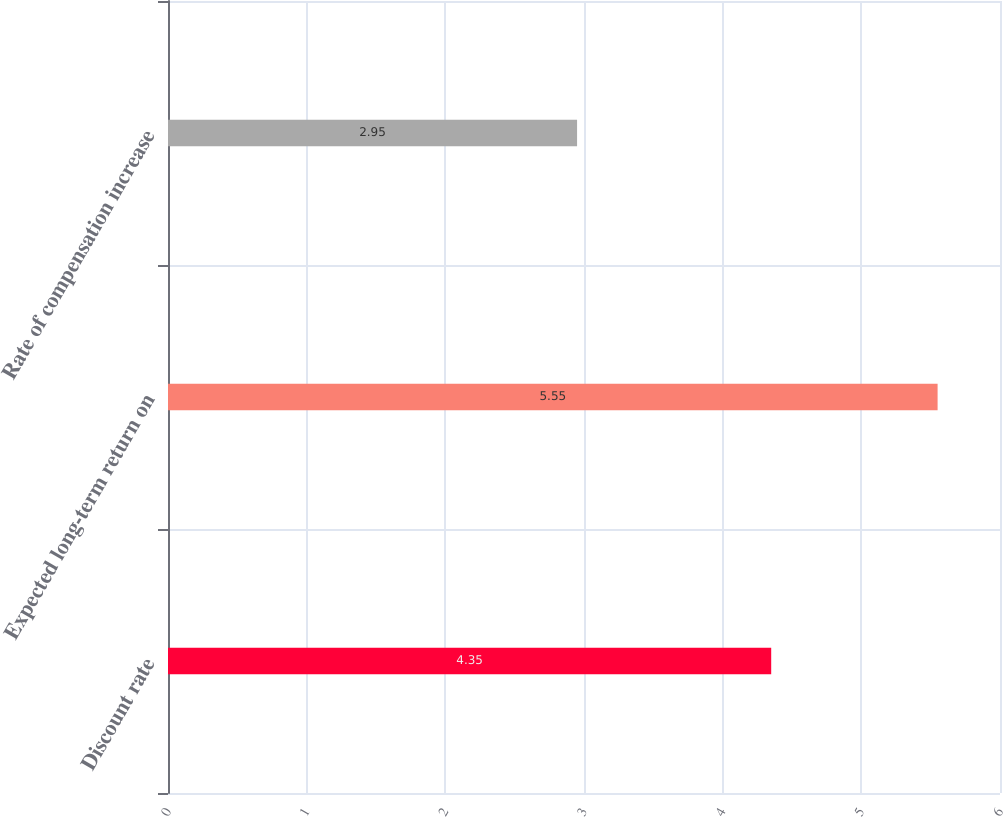Convert chart to OTSL. <chart><loc_0><loc_0><loc_500><loc_500><bar_chart><fcel>Discount rate<fcel>Expected long-term return on<fcel>Rate of compensation increase<nl><fcel>4.35<fcel>5.55<fcel>2.95<nl></chart> 